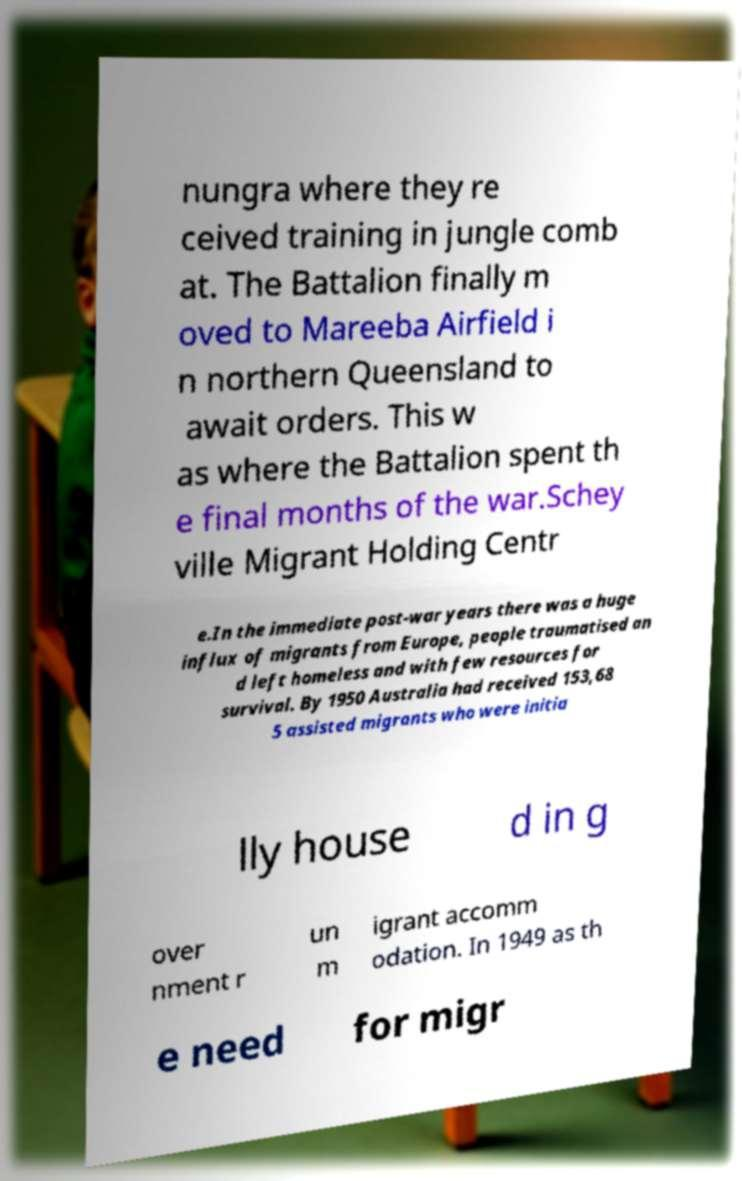Could you extract and type out the text from this image? nungra where they re ceived training in jungle comb at. The Battalion finally m oved to Mareeba Airfield i n northern Queensland to await orders. This w as where the Battalion spent th e final months of the war.Schey ville Migrant Holding Centr e.In the immediate post-war years there was a huge influx of migrants from Europe, people traumatised an d left homeless and with few resources for survival. By 1950 Australia had received 153,68 5 assisted migrants who were initia lly house d in g over nment r un m igrant accomm odation. In 1949 as th e need for migr 